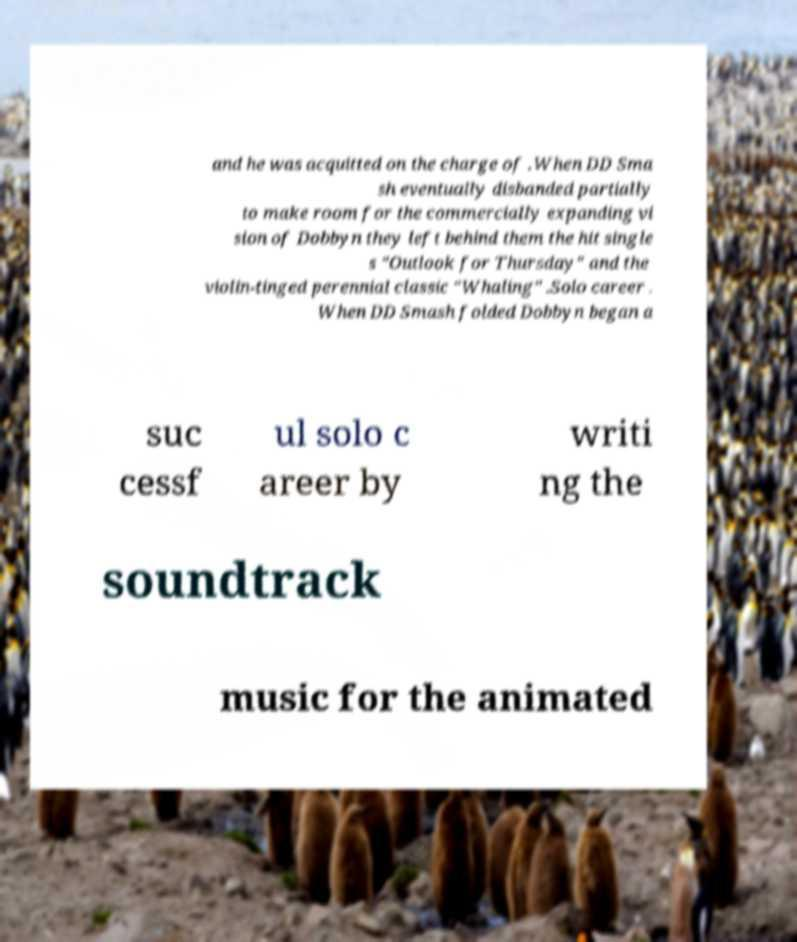Can you accurately transcribe the text from the provided image for me? and he was acquitted on the charge of .When DD Sma sh eventually disbanded partially to make room for the commercially expanding vi sion of Dobbyn they left behind them the hit single s "Outlook for Thursday" and the violin-tinged perennial classic "Whaling" .Solo career . When DD Smash folded Dobbyn began a suc cessf ul solo c areer by writi ng the soundtrack music for the animated 